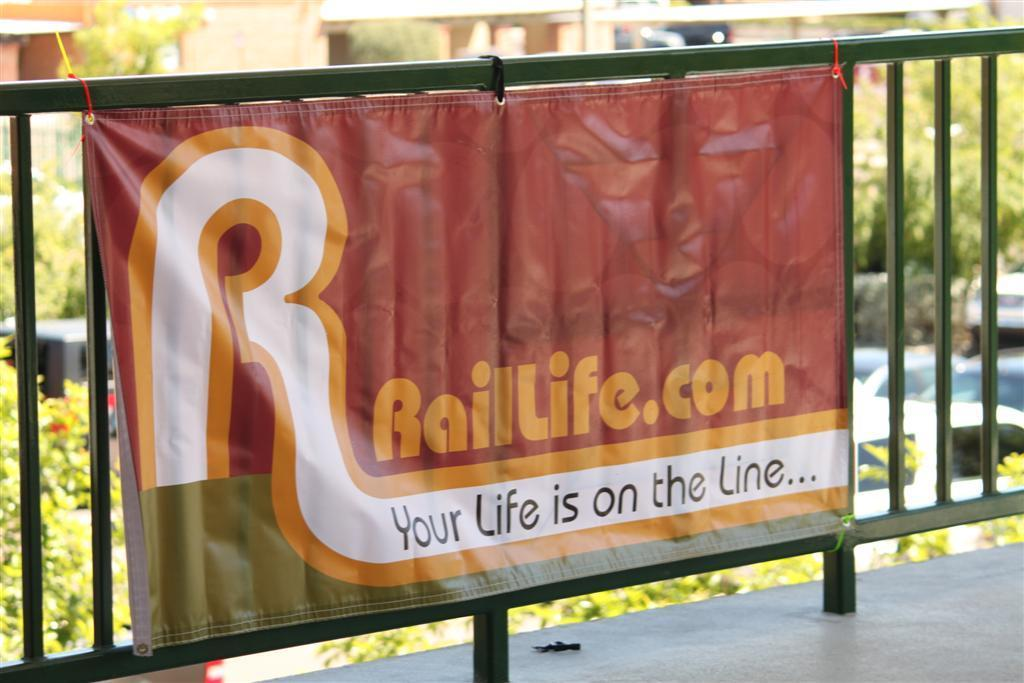<image>
Create a compact narrative representing the image presented. A banner with a slogan of "Your Life is on the Line" hangs from a metal fence. 